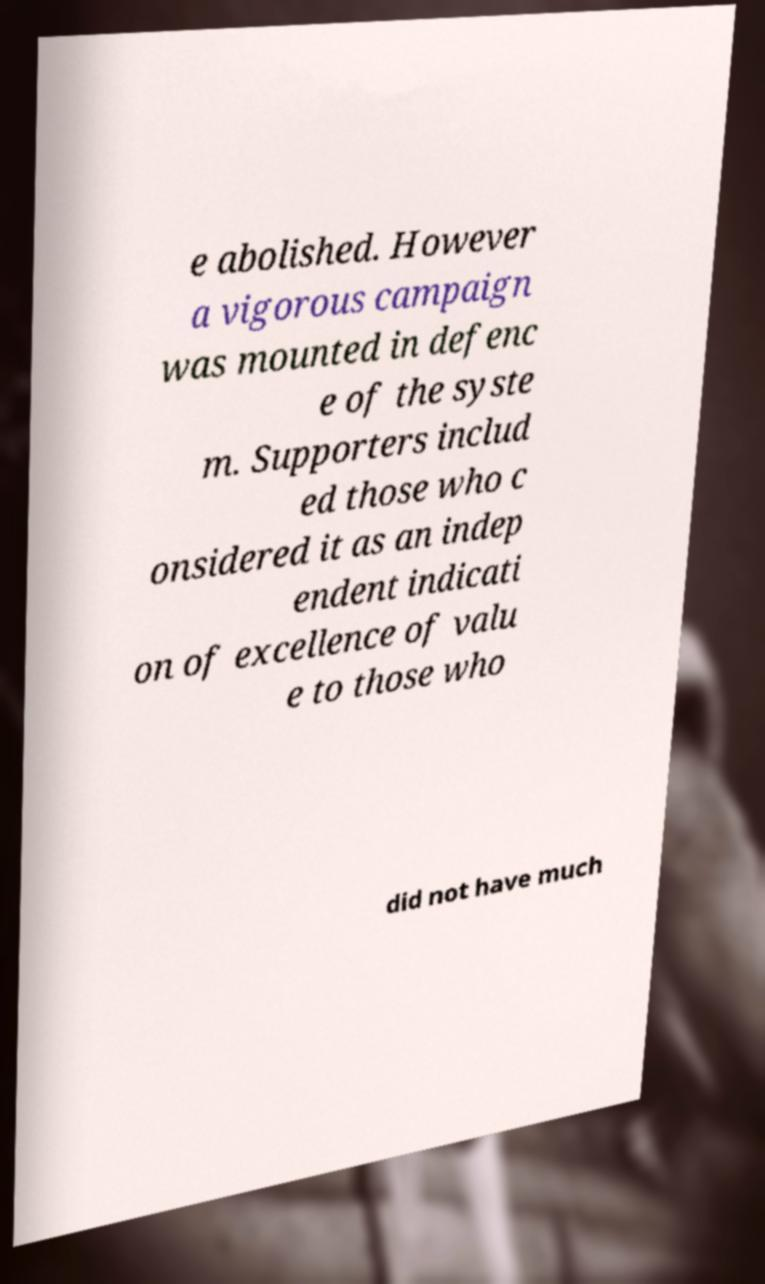I need the written content from this picture converted into text. Can you do that? e abolished. However a vigorous campaign was mounted in defenc e of the syste m. Supporters includ ed those who c onsidered it as an indep endent indicati on of excellence of valu e to those who did not have much 